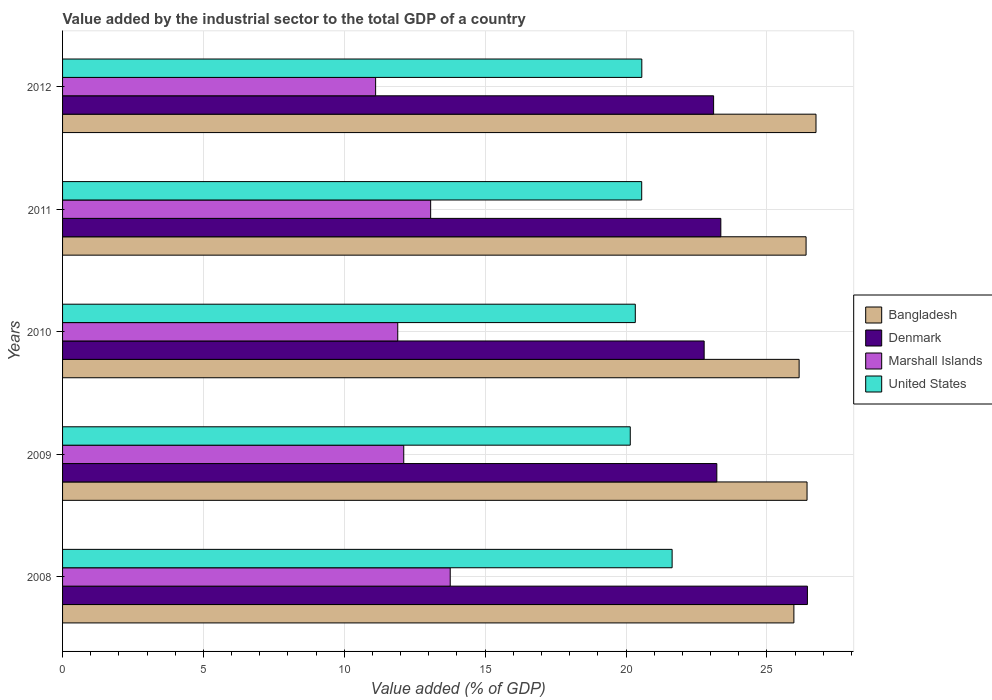How many different coloured bars are there?
Ensure brevity in your answer.  4. What is the label of the 5th group of bars from the top?
Your answer should be very brief. 2008. What is the value added by the industrial sector to the total GDP in Denmark in 2011?
Provide a succinct answer. 23.36. Across all years, what is the maximum value added by the industrial sector to the total GDP in United States?
Provide a succinct answer. 21.64. Across all years, what is the minimum value added by the industrial sector to the total GDP in Marshall Islands?
Your response must be concise. 11.11. What is the total value added by the industrial sector to the total GDP in Denmark in the graph?
Your answer should be very brief. 118.91. What is the difference between the value added by the industrial sector to the total GDP in Marshall Islands in 2008 and that in 2009?
Offer a terse response. 1.65. What is the difference between the value added by the industrial sector to the total GDP in Denmark in 2009 and the value added by the industrial sector to the total GDP in United States in 2011?
Your answer should be compact. 2.67. What is the average value added by the industrial sector to the total GDP in Denmark per year?
Offer a very short reply. 23.78. In the year 2011, what is the difference between the value added by the industrial sector to the total GDP in Marshall Islands and value added by the industrial sector to the total GDP in Denmark?
Ensure brevity in your answer.  -10.3. In how many years, is the value added by the industrial sector to the total GDP in United States greater than 3 %?
Offer a terse response. 5. What is the ratio of the value added by the industrial sector to the total GDP in United States in 2008 to that in 2012?
Give a very brief answer. 1.05. What is the difference between the highest and the second highest value added by the industrial sector to the total GDP in United States?
Ensure brevity in your answer.  1.08. What is the difference between the highest and the lowest value added by the industrial sector to the total GDP in United States?
Offer a very short reply. 1.49. Is it the case that in every year, the sum of the value added by the industrial sector to the total GDP in United States and value added by the industrial sector to the total GDP in Denmark is greater than the sum of value added by the industrial sector to the total GDP in Marshall Islands and value added by the industrial sector to the total GDP in Bangladesh?
Your answer should be very brief. No. What does the 1st bar from the top in 2008 represents?
Ensure brevity in your answer.  United States. How many bars are there?
Your answer should be compact. 20. Are all the bars in the graph horizontal?
Offer a terse response. Yes. How many years are there in the graph?
Make the answer very short. 5. Are the values on the major ticks of X-axis written in scientific E-notation?
Your response must be concise. No. Does the graph contain any zero values?
Your answer should be compact. No. Does the graph contain grids?
Keep it short and to the point. Yes. How many legend labels are there?
Give a very brief answer. 4. How are the legend labels stacked?
Ensure brevity in your answer.  Vertical. What is the title of the graph?
Keep it short and to the point. Value added by the industrial sector to the total GDP of a country. What is the label or title of the X-axis?
Ensure brevity in your answer.  Value added (% of GDP). What is the Value added (% of GDP) in Bangladesh in 2008?
Give a very brief answer. 25.96. What is the Value added (% of GDP) of Denmark in 2008?
Provide a succinct answer. 26.44. What is the Value added (% of GDP) in Marshall Islands in 2008?
Offer a terse response. 13.76. What is the Value added (% of GDP) in United States in 2008?
Provide a short and direct response. 21.64. What is the Value added (% of GDP) of Bangladesh in 2009?
Your answer should be compact. 26.43. What is the Value added (% of GDP) of Denmark in 2009?
Provide a short and direct response. 23.22. What is the Value added (% of GDP) of Marshall Islands in 2009?
Keep it short and to the point. 12.11. What is the Value added (% of GDP) of United States in 2009?
Offer a very short reply. 20.15. What is the Value added (% of GDP) of Bangladesh in 2010?
Offer a terse response. 26.14. What is the Value added (% of GDP) of Denmark in 2010?
Give a very brief answer. 22.77. What is the Value added (% of GDP) of Marshall Islands in 2010?
Offer a terse response. 11.9. What is the Value added (% of GDP) in United States in 2010?
Your answer should be compact. 20.33. What is the Value added (% of GDP) in Bangladesh in 2011?
Your response must be concise. 26.39. What is the Value added (% of GDP) in Denmark in 2011?
Your response must be concise. 23.36. What is the Value added (% of GDP) of Marshall Islands in 2011?
Your answer should be compact. 13.07. What is the Value added (% of GDP) in United States in 2011?
Keep it short and to the point. 20.56. What is the Value added (% of GDP) of Bangladesh in 2012?
Ensure brevity in your answer.  26.74. What is the Value added (% of GDP) of Denmark in 2012?
Keep it short and to the point. 23.11. What is the Value added (% of GDP) of Marshall Islands in 2012?
Make the answer very short. 11.11. What is the Value added (% of GDP) of United States in 2012?
Offer a terse response. 20.56. Across all years, what is the maximum Value added (% of GDP) in Bangladesh?
Keep it short and to the point. 26.74. Across all years, what is the maximum Value added (% of GDP) of Denmark?
Offer a terse response. 26.44. Across all years, what is the maximum Value added (% of GDP) of Marshall Islands?
Your answer should be very brief. 13.76. Across all years, what is the maximum Value added (% of GDP) of United States?
Offer a very short reply. 21.64. Across all years, what is the minimum Value added (% of GDP) of Bangladesh?
Offer a very short reply. 25.96. Across all years, what is the minimum Value added (% of GDP) of Denmark?
Make the answer very short. 22.77. Across all years, what is the minimum Value added (% of GDP) of Marshall Islands?
Give a very brief answer. 11.11. Across all years, what is the minimum Value added (% of GDP) of United States?
Provide a succinct answer. 20.15. What is the total Value added (% of GDP) of Bangladesh in the graph?
Provide a short and direct response. 131.66. What is the total Value added (% of GDP) in Denmark in the graph?
Your response must be concise. 118.91. What is the total Value added (% of GDP) in Marshall Islands in the graph?
Provide a succinct answer. 61.95. What is the total Value added (% of GDP) of United States in the graph?
Your response must be concise. 103.23. What is the difference between the Value added (% of GDP) in Bangladesh in 2008 and that in 2009?
Provide a succinct answer. -0.47. What is the difference between the Value added (% of GDP) in Denmark in 2008 and that in 2009?
Make the answer very short. 3.22. What is the difference between the Value added (% of GDP) of Marshall Islands in 2008 and that in 2009?
Your response must be concise. 1.65. What is the difference between the Value added (% of GDP) of United States in 2008 and that in 2009?
Your answer should be very brief. 1.49. What is the difference between the Value added (% of GDP) of Bangladesh in 2008 and that in 2010?
Ensure brevity in your answer.  -0.19. What is the difference between the Value added (% of GDP) in Denmark in 2008 and that in 2010?
Offer a very short reply. 3.67. What is the difference between the Value added (% of GDP) in Marshall Islands in 2008 and that in 2010?
Keep it short and to the point. 1.86. What is the difference between the Value added (% of GDP) of United States in 2008 and that in 2010?
Provide a succinct answer. 1.31. What is the difference between the Value added (% of GDP) in Bangladesh in 2008 and that in 2011?
Provide a short and direct response. -0.43. What is the difference between the Value added (% of GDP) of Denmark in 2008 and that in 2011?
Your response must be concise. 3.07. What is the difference between the Value added (% of GDP) in Marshall Islands in 2008 and that in 2011?
Your answer should be very brief. 0.69. What is the difference between the Value added (% of GDP) in United States in 2008 and that in 2011?
Provide a short and direct response. 1.08. What is the difference between the Value added (% of GDP) in Bangladesh in 2008 and that in 2012?
Your answer should be compact. -0.78. What is the difference between the Value added (% of GDP) in Denmark in 2008 and that in 2012?
Provide a succinct answer. 3.33. What is the difference between the Value added (% of GDP) of Marshall Islands in 2008 and that in 2012?
Offer a terse response. 2.65. What is the difference between the Value added (% of GDP) in United States in 2008 and that in 2012?
Provide a succinct answer. 1.08. What is the difference between the Value added (% of GDP) in Bangladesh in 2009 and that in 2010?
Provide a succinct answer. 0.28. What is the difference between the Value added (% of GDP) of Denmark in 2009 and that in 2010?
Ensure brevity in your answer.  0.45. What is the difference between the Value added (% of GDP) in Marshall Islands in 2009 and that in 2010?
Your answer should be compact. 0.21. What is the difference between the Value added (% of GDP) of United States in 2009 and that in 2010?
Provide a succinct answer. -0.18. What is the difference between the Value added (% of GDP) of Bangladesh in 2009 and that in 2011?
Your answer should be compact. 0.03. What is the difference between the Value added (% of GDP) of Denmark in 2009 and that in 2011?
Provide a short and direct response. -0.14. What is the difference between the Value added (% of GDP) in Marshall Islands in 2009 and that in 2011?
Give a very brief answer. -0.96. What is the difference between the Value added (% of GDP) of United States in 2009 and that in 2011?
Ensure brevity in your answer.  -0.41. What is the difference between the Value added (% of GDP) in Bangladesh in 2009 and that in 2012?
Keep it short and to the point. -0.32. What is the difference between the Value added (% of GDP) of Denmark in 2009 and that in 2012?
Ensure brevity in your answer.  0.11. What is the difference between the Value added (% of GDP) in United States in 2009 and that in 2012?
Make the answer very short. -0.41. What is the difference between the Value added (% of GDP) in Bangladesh in 2010 and that in 2011?
Provide a short and direct response. -0.25. What is the difference between the Value added (% of GDP) in Denmark in 2010 and that in 2011?
Offer a very short reply. -0.59. What is the difference between the Value added (% of GDP) in Marshall Islands in 2010 and that in 2011?
Your response must be concise. -1.17. What is the difference between the Value added (% of GDP) in United States in 2010 and that in 2011?
Keep it short and to the point. -0.23. What is the difference between the Value added (% of GDP) of Bangladesh in 2010 and that in 2012?
Ensure brevity in your answer.  -0.6. What is the difference between the Value added (% of GDP) of Denmark in 2010 and that in 2012?
Keep it short and to the point. -0.34. What is the difference between the Value added (% of GDP) of Marshall Islands in 2010 and that in 2012?
Provide a succinct answer. 0.79. What is the difference between the Value added (% of GDP) of United States in 2010 and that in 2012?
Make the answer very short. -0.23. What is the difference between the Value added (% of GDP) in Bangladesh in 2011 and that in 2012?
Your answer should be very brief. -0.35. What is the difference between the Value added (% of GDP) in Denmark in 2011 and that in 2012?
Make the answer very short. 0.26. What is the difference between the Value added (% of GDP) in Marshall Islands in 2011 and that in 2012?
Keep it short and to the point. 1.95. What is the difference between the Value added (% of GDP) of United States in 2011 and that in 2012?
Offer a very short reply. -0. What is the difference between the Value added (% of GDP) in Bangladesh in 2008 and the Value added (% of GDP) in Denmark in 2009?
Provide a succinct answer. 2.74. What is the difference between the Value added (% of GDP) in Bangladesh in 2008 and the Value added (% of GDP) in Marshall Islands in 2009?
Provide a short and direct response. 13.85. What is the difference between the Value added (% of GDP) of Bangladesh in 2008 and the Value added (% of GDP) of United States in 2009?
Ensure brevity in your answer.  5.81. What is the difference between the Value added (% of GDP) of Denmark in 2008 and the Value added (% of GDP) of Marshall Islands in 2009?
Offer a very short reply. 14.33. What is the difference between the Value added (% of GDP) of Denmark in 2008 and the Value added (% of GDP) of United States in 2009?
Your answer should be compact. 6.29. What is the difference between the Value added (% of GDP) in Marshall Islands in 2008 and the Value added (% of GDP) in United States in 2009?
Keep it short and to the point. -6.39. What is the difference between the Value added (% of GDP) of Bangladesh in 2008 and the Value added (% of GDP) of Denmark in 2010?
Make the answer very short. 3.19. What is the difference between the Value added (% of GDP) in Bangladesh in 2008 and the Value added (% of GDP) in Marshall Islands in 2010?
Make the answer very short. 14.06. What is the difference between the Value added (% of GDP) in Bangladesh in 2008 and the Value added (% of GDP) in United States in 2010?
Offer a terse response. 5.63. What is the difference between the Value added (% of GDP) of Denmark in 2008 and the Value added (% of GDP) of Marshall Islands in 2010?
Ensure brevity in your answer.  14.54. What is the difference between the Value added (% of GDP) in Denmark in 2008 and the Value added (% of GDP) in United States in 2010?
Keep it short and to the point. 6.11. What is the difference between the Value added (% of GDP) of Marshall Islands in 2008 and the Value added (% of GDP) of United States in 2010?
Ensure brevity in your answer.  -6.57. What is the difference between the Value added (% of GDP) in Bangladesh in 2008 and the Value added (% of GDP) in Denmark in 2011?
Provide a succinct answer. 2.59. What is the difference between the Value added (% of GDP) of Bangladesh in 2008 and the Value added (% of GDP) of Marshall Islands in 2011?
Offer a terse response. 12.89. What is the difference between the Value added (% of GDP) of Bangladesh in 2008 and the Value added (% of GDP) of United States in 2011?
Ensure brevity in your answer.  5.4. What is the difference between the Value added (% of GDP) in Denmark in 2008 and the Value added (% of GDP) in Marshall Islands in 2011?
Your answer should be very brief. 13.37. What is the difference between the Value added (% of GDP) of Denmark in 2008 and the Value added (% of GDP) of United States in 2011?
Offer a terse response. 5.88. What is the difference between the Value added (% of GDP) in Marshall Islands in 2008 and the Value added (% of GDP) in United States in 2011?
Offer a very short reply. -6.8. What is the difference between the Value added (% of GDP) of Bangladesh in 2008 and the Value added (% of GDP) of Denmark in 2012?
Provide a short and direct response. 2.85. What is the difference between the Value added (% of GDP) in Bangladesh in 2008 and the Value added (% of GDP) in Marshall Islands in 2012?
Offer a very short reply. 14.85. What is the difference between the Value added (% of GDP) in Bangladesh in 2008 and the Value added (% of GDP) in United States in 2012?
Offer a very short reply. 5.4. What is the difference between the Value added (% of GDP) in Denmark in 2008 and the Value added (% of GDP) in Marshall Islands in 2012?
Ensure brevity in your answer.  15.33. What is the difference between the Value added (% of GDP) of Denmark in 2008 and the Value added (% of GDP) of United States in 2012?
Ensure brevity in your answer.  5.88. What is the difference between the Value added (% of GDP) of Marshall Islands in 2008 and the Value added (% of GDP) of United States in 2012?
Give a very brief answer. -6.8. What is the difference between the Value added (% of GDP) of Bangladesh in 2009 and the Value added (% of GDP) of Denmark in 2010?
Ensure brevity in your answer.  3.65. What is the difference between the Value added (% of GDP) of Bangladesh in 2009 and the Value added (% of GDP) of Marshall Islands in 2010?
Ensure brevity in your answer.  14.53. What is the difference between the Value added (% of GDP) of Bangladesh in 2009 and the Value added (% of GDP) of United States in 2010?
Offer a terse response. 6.1. What is the difference between the Value added (% of GDP) in Denmark in 2009 and the Value added (% of GDP) in Marshall Islands in 2010?
Your answer should be compact. 11.33. What is the difference between the Value added (% of GDP) in Denmark in 2009 and the Value added (% of GDP) in United States in 2010?
Your response must be concise. 2.89. What is the difference between the Value added (% of GDP) of Marshall Islands in 2009 and the Value added (% of GDP) of United States in 2010?
Your answer should be compact. -8.22. What is the difference between the Value added (% of GDP) of Bangladesh in 2009 and the Value added (% of GDP) of Denmark in 2011?
Your answer should be compact. 3.06. What is the difference between the Value added (% of GDP) of Bangladesh in 2009 and the Value added (% of GDP) of Marshall Islands in 2011?
Provide a succinct answer. 13.36. What is the difference between the Value added (% of GDP) of Bangladesh in 2009 and the Value added (% of GDP) of United States in 2011?
Keep it short and to the point. 5.87. What is the difference between the Value added (% of GDP) of Denmark in 2009 and the Value added (% of GDP) of Marshall Islands in 2011?
Ensure brevity in your answer.  10.16. What is the difference between the Value added (% of GDP) of Denmark in 2009 and the Value added (% of GDP) of United States in 2011?
Offer a very short reply. 2.67. What is the difference between the Value added (% of GDP) of Marshall Islands in 2009 and the Value added (% of GDP) of United States in 2011?
Your answer should be very brief. -8.45. What is the difference between the Value added (% of GDP) in Bangladesh in 2009 and the Value added (% of GDP) in Denmark in 2012?
Your answer should be compact. 3.32. What is the difference between the Value added (% of GDP) of Bangladesh in 2009 and the Value added (% of GDP) of Marshall Islands in 2012?
Provide a short and direct response. 15.31. What is the difference between the Value added (% of GDP) of Bangladesh in 2009 and the Value added (% of GDP) of United States in 2012?
Your answer should be compact. 5.87. What is the difference between the Value added (% of GDP) in Denmark in 2009 and the Value added (% of GDP) in Marshall Islands in 2012?
Give a very brief answer. 12.11. What is the difference between the Value added (% of GDP) of Denmark in 2009 and the Value added (% of GDP) of United States in 2012?
Your answer should be very brief. 2.66. What is the difference between the Value added (% of GDP) in Marshall Islands in 2009 and the Value added (% of GDP) in United States in 2012?
Keep it short and to the point. -8.45. What is the difference between the Value added (% of GDP) in Bangladesh in 2010 and the Value added (% of GDP) in Denmark in 2011?
Provide a succinct answer. 2.78. What is the difference between the Value added (% of GDP) in Bangladesh in 2010 and the Value added (% of GDP) in Marshall Islands in 2011?
Offer a terse response. 13.08. What is the difference between the Value added (% of GDP) of Bangladesh in 2010 and the Value added (% of GDP) of United States in 2011?
Make the answer very short. 5.59. What is the difference between the Value added (% of GDP) of Denmark in 2010 and the Value added (% of GDP) of Marshall Islands in 2011?
Your answer should be very brief. 9.71. What is the difference between the Value added (% of GDP) in Denmark in 2010 and the Value added (% of GDP) in United States in 2011?
Your answer should be very brief. 2.22. What is the difference between the Value added (% of GDP) in Marshall Islands in 2010 and the Value added (% of GDP) in United States in 2011?
Provide a short and direct response. -8.66. What is the difference between the Value added (% of GDP) of Bangladesh in 2010 and the Value added (% of GDP) of Denmark in 2012?
Offer a terse response. 3.04. What is the difference between the Value added (% of GDP) in Bangladesh in 2010 and the Value added (% of GDP) in Marshall Islands in 2012?
Your response must be concise. 15.03. What is the difference between the Value added (% of GDP) of Bangladesh in 2010 and the Value added (% of GDP) of United States in 2012?
Keep it short and to the point. 5.58. What is the difference between the Value added (% of GDP) of Denmark in 2010 and the Value added (% of GDP) of Marshall Islands in 2012?
Your answer should be compact. 11.66. What is the difference between the Value added (% of GDP) of Denmark in 2010 and the Value added (% of GDP) of United States in 2012?
Give a very brief answer. 2.21. What is the difference between the Value added (% of GDP) of Marshall Islands in 2010 and the Value added (% of GDP) of United States in 2012?
Offer a very short reply. -8.66. What is the difference between the Value added (% of GDP) of Bangladesh in 2011 and the Value added (% of GDP) of Denmark in 2012?
Your response must be concise. 3.28. What is the difference between the Value added (% of GDP) of Bangladesh in 2011 and the Value added (% of GDP) of Marshall Islands in 2012?
Your answer should be very brief. 15.28. What is the difference between the Value added (% of GDP) in Bangladesh in 2011 and the Value added (% of GDP) in United States in 2012?
Ensure brevity in your answer.  5.83. What is the difference between the Value added (% of GDP) of Denmark in 2011 and the Value added (% of GDP) of Marshall Islands in 2012?
Give a very brief answer. 12.25. What is the difference between the Value added (% of GDP) in Denmark in 2011 and the Value added (% of GDP) in United States in 2012?
Provide a short and direct response. 2.8. What is the difference between the Value added (% of GDP) in Marshall Islands in 2011 and the Value added (% of GDP) in United States in 2012?
Offer a very short reply. -7.49. What is the average Value added (% of GDP) of Bangladesh per year?
Provide a short and direct response. 26.33. What is the average Value added (% of GDP) of Denmark per year?
Ensure brevity in your answer.  23.78. What is the average Value added (% of GDP) of Marshall Islands per year?
Give a very brief answer. 12.39. What is the average Value added (% of GDP) of United States per year?
Your response must be concise. 20.65. In the year 2008, what is the difference between the Value added (% of GDP) of Bangladesh and Value added (% of GDP) of Denmark?
Your answer should be compact. -0.48. In the year 2008, what is the difference between the Value added (% of GDP) of Bangladesh and Value added (% of GDP) of Marshall Islands?
Offer a very short reply. 12.2. In the year 2008, what is the difference between the Value added (% of GDP) in Bangladesh and Value added (% of GDP) in United States?
Give a very brief answer. 4.32. In the year 2008, what is the difference between the Value added (% of GDP) of Denmark and Value added (% of GDP) of Marshall Islands?
Your answer should be compact. 12.68. In the year 2008, what is the difference between the Value added (% of GDP) of Denmark and Value added (% of GDP) of United States?
Your answer should be very brief. 4.8. In the year 2008, what is the difference between the Value added (% of GDP) in Marshall Islands and Value added (% of GDP) in United States?
Keep it short and to the point. -7.88. In the year 2009, what is the difference between the Value added (% of GDP) of Bangladesh and Value added (% of GDP) of Denmark?
Keep it short and to the point. 3.2. In the year 2009, what is the difference between the Value added (% of GDP) of Bangladesh and Value added (% of GDP) of Marshall Islands?
Offer a terse response. 14.32. In the year 2009, what is the difference between the Value added (% of GDP) of Bangladesh and Value added (% of GDP) of United States?
Ensure brevity in your answer.  6.28. In the year 2009, what is the difference between the Value added (% of GDP) in Denmark and Value added (% of GDP) in Marshall Islands?
Ensure brevity in your answer.  11.11. In the year 2009, what is the difference between the Value added (% of GDP) in Denmark and Value added (% of GDP) in United States?
Make the answer very short. 3.07. In the year 2009, what is the difference between the Value added (% of GDP) in Marshall Islands and Value added (% of GDP) in United States?
Your response must be concise. -8.04. In the year 2010, what is the difference between the Value added (% of GDP) of Bangladesh and Value added (% of GDP) of Denmark?
Your answer should be compact. 3.37. In the year 2010, what is the difference between the Value added (% of GDP) in Bangladesh and Value added (% of GDP) in Marshall Islands?
Provide a succinct answer. 14.25. In the year 2010, what is the difference between the Value added (% of GDP) of Bangladesh and Value added (% of GDP) of United States?
Offer a very short reply. 5.82. In the year 2010, what is the difference between the Value added (% of GDP) of Denmark and Value added (% of GDP) of Marshall Islands?
Ensure brevity in your answer.  10.88. In the year 2010, what is the difference between the Value added (% of GDP) of Denmark and Value added (% of GDP) of United States?
Your answer should be compact. 2.44. In the year 2010, what is the difference between the Value added (% of GDP) of Marshall Islands and Value added (% of GDP) of United States?
Your response must be concise. -8.43. In the year 2011, what is the difference between the Value added (% of GDP) in Bangladesh and Value added (% of GDP) in Denmark?
Keep it short and to the point. 3.03. In the year 2011, what is the difference between the Value added (% of GDP) of Bangladesh and Value added (% of GDP) of Marshall Islands?
Make the answer very short. 13.33. In the year 2011, what is the difference between the Value added (% of GDP) in Bangladesh and Value added (% of GDP) in United States?
Offer a very short reply. 5.83. In the year 2011, what is the difference between the Value added (% of GDP) in Denmark and Value added (% of GDP) in Marshall Islands?
Provide a short and direct response. 10.3. In the year 2011, what is the difference between the Value added (% of GDP) of Denmark and Value added (% of GDP) of United States?
Ensure brevity in your answer.  2.81. In the year 2011, what is the difference between the Value added (% of GDP) in Marshall Islands and Value added (% of GDP) in United States?
Your answer should be very brief. -7.49. In the year 2012, what is the difference between the Value added (% of GDP) in Bangladesh and Value added (% of GDP) in Denmark?
Provide a succinct answer. 3.63. In the year 2012, what is the difference between the Value added (% of GDP) of Bangladesh and Value added (% of GDP) of Marshall Islands?
Ensure brevity in your answer.  15.63. In the year 2012, what is the difference between the Value added (% of GDP) of Bangladesh and Value added (% of GDP) of United States?
Offer a very short reply. 6.18. In the year 2012, what is the difference between the Value added (% of GDP) in Denmark and Value added (% of GDP) in Marshall Islands?
Provide a succinct answer. 12. In the year 2012, what is the difference between the Value added (% of GDP) in Denmark and Value added (% of GDP) in United States?
Make the answer very short. 2.55. In the year 2012, what is the difference between the Value added (% of GDP) in Marshall Islands and Value added (% of GDP) in United States?
Provide a short and direct response. -9.45. What is the ratio of the Value added (% of GDP) in Bangladesh in 2008 to that in 2009?
Provide a succinct answer. 0.98. What is the ratio of the Value added (% of GDP) in Denmark in 2008 to that in 2009?
Offer a terse response. 1.14. What is the ratio of the Value added (% of GDP) of Marshall Islands in 2008 to that in 2009?
Make the answer very short. 1.14. What is the ratio of the Value added (% of GDP) of United States in 2008 to that in 2009?
Your answer should be very brief. 1.07. What is the ratio of the Value added (% of GDP) in Denmark in 2008 to that in 2010?
Provide a short and direct response. 1.16. What is the ratio of the Value added (% of GDP) in Marshall Islands in 2008 to that in 2010?
Your answer should be compact. 1.16. What is the ratio of the Value added (% of GDP) of United States in 2008 to that in 2010?
Offer a terse response. 1.06. What is the ratio of the Value added (% of GDP) of Bangladesh in 2008 to that in 2011?
Offer a terse response. 0.98. What is the ratio of the Value added (% of GDP) of Denmark in 2008 to that in 2011?
Make the answer very short. 1.13. What is the ratio of the Value added (% of GDP) in Marshall Islands in 2008 to that in 2011?
Offer a very short reply. 1.05. What is the ratio of the Value added (% of GDP) in United States in 2008 to that in 2011?
Provide a succinct answer. 1.05. What is the ratio of the Value added (% of GDP) in Bangladesh in 2008 to that in 2012?
Offer a terse response. 0.97. What is the ratio of the Value added (% of GDP) of Denmark in 2008 to that in 2012?
Make the answer very short. 1.14. What is the ratio of the Value added (% of GDP) of Marshall Islands in 2008 to that in 2012?
Your answer should be very brief. 1.24. What is the ratio of the Value added (% of GDP) of United States in 2008 to that in 2012?
Your answer should be compact. 1.05. What is the ratio of the Value added (% of GDP) of Bangladesh in 2009 to that in 2010?
Give a very brief answer. 1.01. What is the ratio of the Value added (% of GDP) of Denmark in 2009 to that in 2010?
Offer a terse response. 1.02. What is the ratio of the Value added (% of GDP) in Marshall Islands in 2009 to that in 2010?
Your answer should be compact. 1.02. What is the ratio of the Value added (% of GDP) of United States in 2009 to that in 2010?
Provide a succinct answer. 0.99. What is the ratio of the Value added (% of GDP) of Bangladesh in 2009 to that in 2011?
Your answer should be compact. 1. What is the ratio of the Value added (% of GDP) of Marshall Islands in 2009 to that in 2011?
Keep it short and to the point. 0.93. What is the ratio of the Value added (% of GDP) in United States in 2009 to that in 2011?
Make the answer very short. 0.98. What is the ratio of the Value added (% of GDP) of Bangladesh in 2009 to that in 2012?
Offer a terse response. 0.99. What is the ratio of the Value added (% of GDP) of Marshall Islands in 2009 to that in 2012?
Provide a succinct answer. 1.09. What is the ratio of the Value added (% of GDP) of United States in 2009 to that in 2012?
Your answer should be very brief. 0.98. What is the ratio of the Value added (% of GDP) in Bangladesh in 2010 to that in 2011?
Keep it short and to the point. 0.99. What is the ratio of the Value added (% of GDP) in Denmark in 2010 to that in 2011?
Your response must be concise. 0.97. What is the ratio of the Value added (% of GDP) of Marshall Islands in 2010 to that in 2011?
Your answer should be compact. 0.91. What is the ratio of the Value added (% of GDP) of United States in 2010 to that in 2011?
Keep it short and to the point. 0.99. What is the ratio of the Value added (% of GDP) of Bangladesh in 2010 to that in 2012?
Offer a very short reply. 0.98. What is the ratio of the Value added (% of GDP) of Denmark in 2010 to that in 2012?
Ensure brevity in your answer.  0.99. What is the ratio of the Value added (% of GDP) of Marshall Islands in 2010 to that in 2012?
Keep it short and to the point. 1.07. What is the ratio of the Value added (% of GDP) in United States in 2010 to that in 2012?
Keep it short and to the point. 0.99. What is the ratio of the Value added (% of GDP) in Denmark in 2011 to that in 2012?
Your response must be concise. 1.01. What is the ratio of the Value added (% of GDP) of Marshall Islands in 2011 to that in 2012?
Your answer should be very brief. 1.18. What is the ratio of the Value added (% of GDP) of United States in 2011 to that in 2012?
Your answer should be very brief. 1. What is the difference between the highest and the second highest Value added (% of GDP) of Bangladesh?
Ensure brevity in your answer.  0.32. What is the difference between the highest and the second highest Value added (% of GDP) in Denmark?
Keep it short and to the point. 3.07. What is the difference between the highest and the second highest Value added (% of GDP) of Marshall Islands?
Ensure brevity in your answer.  0.69. What is the difference between the highest and the second highest Value added (% of GDP) of United States?
Provide a succinct answer. 1.08. What is the difference between the highest and the lowest Value added (% of GDP) in Bangladesh?
Give a very brief answer. 0.78. What is the difference between the highest and the lowest Value added (% of GDP) of Denmark?
Your answer should be very brief. 3.67. What is the difference between the highest and the lowest Value added (% of GDP) of Marshall Islands?
Make the answer very short. 2.65. What is the difference between the highest and the lowest Value added (% of GDP) in United States?
Ensure brevity in your answer.  1.49. 